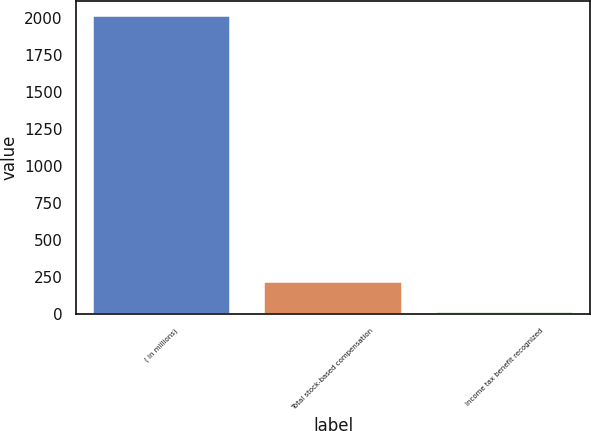Convert chart. <chart><loc_0><loc_0><loc_500><loc_500><bar_chart><fcel>( in millions)<fcel>Total stock-based compensation<fcel>Income tax benefit recognized<nl><fcel>2016<fcel>216.9<fcel>17<nl></chart> 